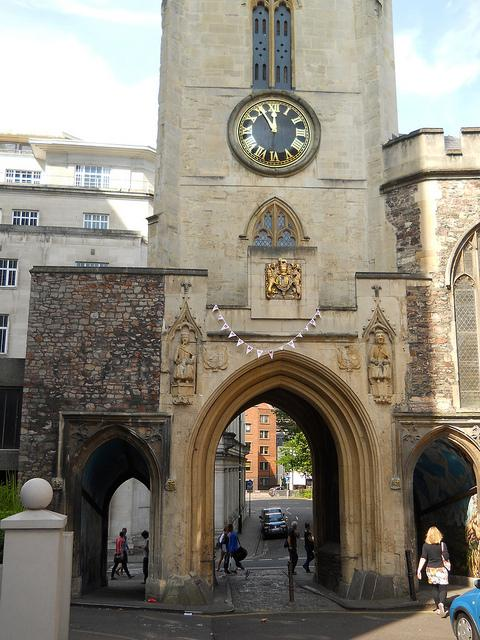What numeral system is used on the clock? roman 